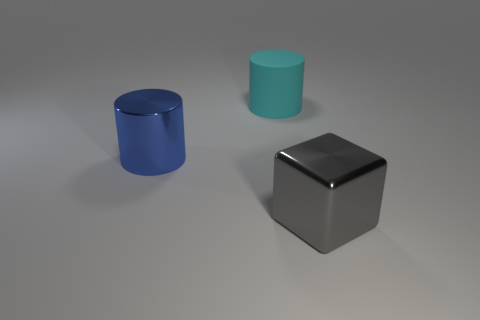Are there an equal number of big metal cylinders behind the cyan object and cylinders?
Provide a short and direct response. No. Is there any other thing that has the same size as the gray metallic thing?
Provide a succinct answer. Yes. What is the color of the large matte thing that is the same shape as the blue metallic thing?
Provide a succinct answer. Cyan. How many other things have the same shape as the blue object?
Your answer should be very brief. 1. How many blue metallic blocks are there?
Give a very brief answer. 0. Are there any big red cylinders that have the same material as the large cyan cylinder?
Provide a short and direct response. No. Does the object that is on the left side of the rubber cylinder have the same size as the cylinder right of the blue metal cylinder?
Ensure brevity in your answer.  Yes. What size is the thing that is right of the cyan matte cylinder?
Keep it short and to the point. Large. Is there a big metallic cylinder of the same color as the big matte object?
Offer a terse response. No. Is there a big cylinder behind the large shiny object behind the gray metallic cube?
Provide a short and direct response. Yes. 